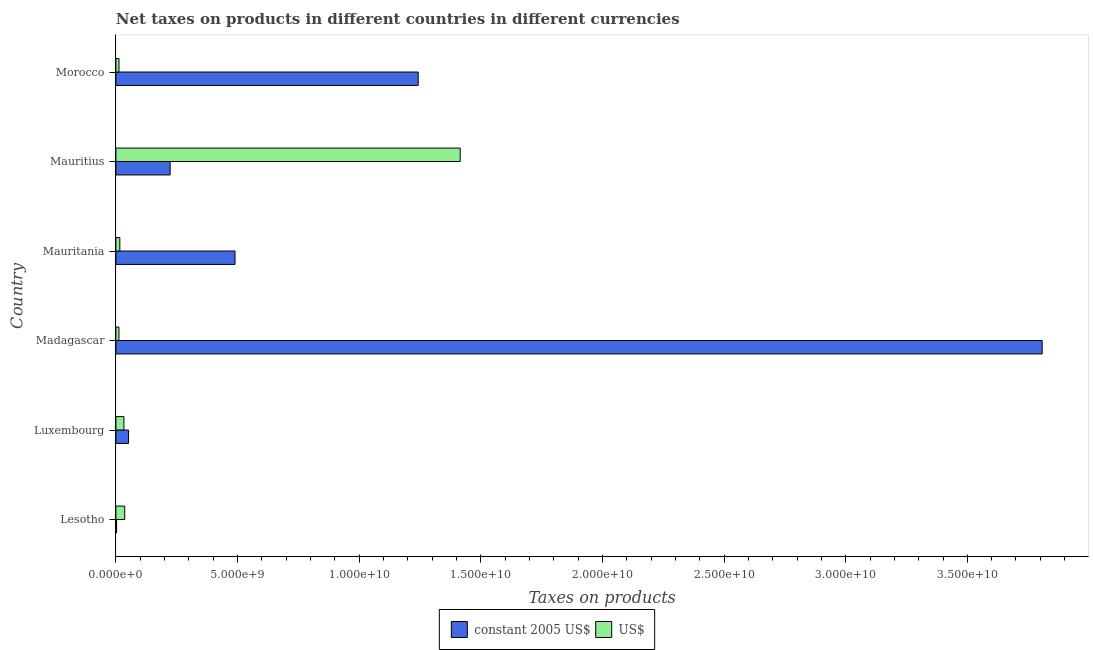How many groups of bars are there?
Your answer should be compact. 6. Are the number of bars per tick equal to the number of legend labels?
Make the answer very short. Yes. Are the number of bars on each tick of the Y-axis equal?
Your answer should be very brief. Yes. How many bars are there on the 5th tick from the bottom?
Provide a short and direct response. 2. What is the label of the 5th group of bars from the top?
Offer a terse response. Luxembourg. In how many cases, is the number of bars for a given country not equal to the number of legend labels?
Your answer should be compact. 0. What is the net taxes in constant 2005 us$ in Lesotho?
Offer a very short reply. 2.91e+07. Across all countries, what is the maximum net taxes in us$?
Your response must be concise. 1.42e+1. Across all countries, what is the minimum net taxes in us$?
Offer a very short reply. 1.26e+08. In which country was the net taxes in constant 2005 us$ maximum?
Offer a very short reply. Madagascar. In which country was the net taxes in us$ minimum?
Offer a terse response. Madagascar. What is the total net taxes in us$ in the graph?
Give a very brief answer. 1.53e+1. What is the difference between the net taxes in us$ in Luxembourg and that in Madagascar?
Ensure brevity in your answer.  2.04e+08. What is the difference between the net taxes in constant 2005 us$ in Luxembourg and the net taxes in us$ in Lesotho?
Make the answer very short. 1.57e+08. What is the average net taxes in constant 2005 us$ per country?
Your answer should be compact. 9.70e+09. What is the difference between the net taxes in us$ and net taxes in constant 2005 us$ in Luxembourg?
Give a very brief answer. -1.89e+08. In how many countries, is the net taxes in constant 2005 us$ greater than 19000000000 units?
Provide a succinct answer. 1. What is the ratio of the net taxes in us$ in Lesotho to that in Morocco?
Provide a short and direct response. 2.85. Is the net taxes in us$ in Luxembourg less than that in Mauritania?
Give a very brief answer. No. Is the difference between the net taxes in us$ in Luxembourg and Madagascar greater than the difference between the net taxes in constant 2005 us$ in Luxembourg and Madagascar?
Provide a succinct answer. Yes. What is the difference between the highest and the second highest net taxes in us$?
Make the answer very short. 1.38e+1. What is the difference between the highest and the lowest net taxes in us$?
Provide a short and direct response. 1.40e+1. In how many countries, is the net taxes in constant 2005 us$ greater than the average net taxes in constant 2005 us$ taken over all countries?
Your answer should be compact. 2. Is the sum of the net taxes in us$ in Madagascar and Mauritius greater than the maximum net taxes in constant 2005 us$ across all countries?
Make the answer very short. No. What does the 1st bar from the top in Madagascar represents?
Provide a short and direct response. US$. What does the 1st bar from the bottom in Mauritius represents?
Make the answer very short. Constant 2005 us$. How many countries are there in the graph?
Give a very brief answer. 6. Does the graph contain grids?
Provide a succinct answer. No. Where does the legend appear in the graph?
Your answer should be very brief. Bottom center. What is the title of the graph?
Your answer should be very brief. Net taxes on products in different countries in different currencies. Does "Under-five" appear as one of the legend labels in the graph?
Offer a very short reply. No. What is the label or title of the X-axis?
Ensure brevity in your answer.  Taxes on products. What is the label or title of the Y-axis?
Your response must be concise. Country. What is the Taxes on products in constant 2005 US$ in Lesotho?
Offer a very short reply. 2.91e+07. What is the Taxes on products of US$ in Lesotho?
Your response must be concise. 3.63e+08. What is the Taxes on products in constant 2005 US$ in Luxembourg?
Keep it short and to the point. 5.20e+08. What is the Taxes on products in US$ in Luxembourg?
Provide a succinct answer. 3.30e+08. What is the Taxes on products of constant 2005 US$ in Madagascar?
Make the answer very short. 3.81e+1. What is the Taxes on products of US$ in Madagascar?
Offer a terse response. 1.26e+08. What is the Taxes on products in constant 2005 US$ in Mauritania?
Your response must be concise. 4.90e+09. What is the Taxes on products of US$ in Mauritania?
Your answer should be compact. 1.62e+08. What is the Taxes on products in constant 2005 US$ in Mauritius?
Give a very brief answer. 2.23e+09. What is the Taxes on products in US$ in Mauritius?
Offer a terse response. 1.42e+1. What is the Taxes on products in constant 2005 US$ in Morocco?
Your answer should be very brief. 1.24e+1. What is the Taxes on products in US$ in Morocco?
Make the answer very short. 1.27e+08. Across all countries, what is the maximum Taxes on products of constant 2005 US$?
Ensure brevity in your answer.  3.81e+1. Across all countries, what is the maximum Taxes on products of US$?
Provide a succinct answer. 1.42e+1. Across all countries, what is the minimum Taxes on products of constant 2005 US$?
Your answer should be very brief. 2.91e+07. Across all countries, what is the minimum Taxes on products of US$?
Keep it short and to the point. 1.26e+08. What is the total Taxes on products in constant 2005 US$ in the graph?
Offer a very short reply. 5.82e+1. What is the total Taxes on products in US$ in the graph?
Offer a terse response. 1.53e+1. What is the difference between the Taxes on products in constant 2005 US$ in Lesotho and that in Luxembourg?
Offer a terse response. -4.91e+08. What is the difference between the Taxes on products in US$ in Lesotho and that in Luxembourg?
Your response must be concise. 3.26e+07. What is the difference between the Taxes on products in constant 2005 US$ in Lesotho and that in Madagascar?
Provide a succinct answer. -3.80e+1. What is the difference between the Taxes on products of US$ in Lesotho and that in Madagascar?
Give a very brief answer. 2.37e+08. What is the difference between the Taxes on products in constant 2005 US$ in Lesotho and that in Mauritania?
Ensure brevity in your answer.  -4.87e+09. What is the difference between the Taxes on products in US$ in Lesotho and that in Mauritania?
Offer a very short reply. 2.01e+08. What is the difference between the Taxes on products of constant 2005 US$ in Lesotho and that in Mauritius?
Your answer should be compact. -2.20e+09. What is the difference between the Taxes on products in US$ in Lesotho and that in Mauritius?
Your answer should be very brief. -1.38e+1. What is the difference between the Taxes on products in constant 2005 US$ in Lesotho and that in Morocco?
Provide a short and direct response. -1.24e+1. What is the difference between the Taxes on products of US$ in Lesotho and that in Morocco?
Your response must be concise. 2.36e+08. What is the difference between the Taxes on products in constant 2005 US$ in Luxembourg and that in Madagascar?
Make the answer very short. -3.76e+1. What is the difference between the Taxes on products of US$ in Luxembourg and that in Madagascar?
Provide a succinct answer. 2.04e+08. What is the difference between the Taxes on products of constant 2005 US$ in Luxembourg and that in Mauritania?
Offer a terse response. -4.38e+09. What is the difference between the Taxes on products of US$ in Luxembourg and that in Mauritania?
Ensure brevity in your answer.  1.69e+08. What is the difference between the Taxes on products in constant 2005 US$ in Luxembourg and that in Mauritius?
Offer a very short reply. -1.71e+09. What is the difference between the Taxes on products in US$ in Luxembourg and that in Mauritius?
Provide a short and direct response. -1.38e+1. What is the difference between the Taxes on products in constant 2005 US$ in Luxembourg and that in Morocco?
Your answer should be very brief. -1.19e+1. What is the difference between the Taxes on products of US$ in Luxembourg and that in Morocco?
Your answer should be compact. 2.03e+08. What is the difference between the Taxes on products in constant 2005 US$ in Madagascar and that in Mauritania?
Your response must be concise. 3.32e+1. What is the difference between the Taxes on products of US$ in Madagascar and that in Mauritania?
Offer a terse response. -3.56e+07. What is the difference between the Taxes on products of constant 2005 US$ in Madagascar and that in Mauritius?
Make the answer very short. 3.58e+1. What is the difference between the Taxes on products in US$ in Madagascar and that in Mauritius?
Your answer should be compact. -1.40e+1. What is the difference between the Taxes on products in constant 2005 US$ in Madagascar and that in Morocco?
Offer a very short reply. 2.56e+1. What is the difference between the Taxes on products in US$ in Madagascar and that in Morocco?
Make the answer very short. -1.25e+06. What is the difference between the Taxes on products of constant 2005 US$ in Mauritania and that in Mauritius?
Make the answer very short. 2.67e+09. What is the difference between the Taxes on products of US$ in Mauritania and that in Mauritius?
Your answer should be very brief. -1.40e+1. What is the difference between the Taxes on products in constant 2005 US$ in Mauritania and that in Morocco?
Offer a very short reply. -7.53e+09. What is the difference between the Taxes on products in US$ in Mauritania and that in Morocco?
Your answer should be very brief. 3.43e+07. What is the difference between the Taxes on products in constant 2005 US$ in Mauritius and that in Morocco?
Offer a very short reply. -1.02e+1. What is the difference between the Taxes on products in US$ in Mauritius and that in Morocco?
Your answer should be compact. 1.40e+1. What is the difference between the Taxes on products of constant 2005 US$ in Lesotho and the Taxes on products of US$ in Luxembourg?
Keep it short and to the point. -3.01e+08. What is the difference between the Taxes on products of constant 2005 US$ in Lesotho and the Taxes on products of US$ in Madagascar?
Provide a succinct answer. -9.69e+07. What is the difference between the Taxes on products of constant 2005 US$ in Lesotho and the Taxes on products of US$ in Mauritania?
Provide a succinct answer. -1.32e+08. What is the difference between the Taxes on products in constant 2005 US$ in Lesotho and the Taxes on products in US$ in Mauritius?
Provide a succinct answer. -1.41e+1. What is the difference between the Taxes on products in constant 2005 US$ in Lesotho and the Taxes on products in US$ in Morocco?
Your answer should be very brief. -9.82e+07. What is the difference between the Taxes on products in constant 2005 US$ in Luxembourg and the Taxes on products in US$ in Madagascar?
Your answer should be very brief. 3.94e+08. What is the difference between the Taxes on products in constant 2005 US$ in Luxembourg and the Taxes on products in US$ in Mauritania?
Ensure brevity in your answer.  3.58e+08. What is the difference between the Taxes on products of constant 2005 US$ in Luxembourg and the Taxes on products of US$ in Mauritius?
Keep it short and to the point. -1.36e+1. What is the difference between the Taxes on products of constant 2005 US$ in Luxembourg and the Taxes on products of US$ in Morocco?
Your answer should be very brief. 3.92e+08. What is the difference between the Taxes on products of constant 2005 US$ in Madagascar and the Taxes on products of US$ in Mauritania?
Provide a succinct answer. 3.79e+1. What is the difference between the Taxes on products in constant 2005 US$ in Madagascar and the Taxes on products in US$ in Mauritius?
Offer a terse response. 2.39e+1. What is the difference between the Taxes on products of constant 2005 US$ in Madagascar and the Taxes on products of US$ in Morocco?
Keep it short and to the point. 3.79e+1. What is the difference between the Taxes on products of constant 2005 US$ in Mauritania and the Taxes on products of US$ in Mauritius?
Make the answer very short. -9.26e+09. What is the difference between the Taxes on products in constant 2005 US$ in Mauritania and the Taxes on products in US$ in Morocco?
Keep it short and to the point. 4.77e+09. What is the difference between the Taxes on products in constant 2005 US$ in Mauritius and the Taxes on products in US$ in Morocco?
Keep it short and to the point. 2.10e+09. What is the average Taxes on products of constant 2005 US$ per country?
Your answer should be compact. 9.70e+09. What is the average Taxes on products of US$ per country?
Ensure brevity in your answer.  2.54e+09. What is the difference between the Taxes on products of constant 2005 US$ and Taxes on products of US$ in Lesotho?
Offer a terse response. -3.34e+08. What is the difference between the Taxes on products in constant 2005 US$ and Taxes on products in US$ in Luxembourg?
Offer a terse response. 1.89e+08. What is the difference between the Taxes on products of constant 2005 US$ and Taxes on products of US$ in Madagascar?
Your response must be concise. 3.80e+1. What is the difference between the Taxes on products in constant 2005 US$ and Taxes on products in US$ in Mauritania?
Make the answer very short. 4.74e+09. What is the difference between the Taxes on products of constant 2005 US$ and Taxes on products of US$ in Mauritius?
Offer a terse response. -1.19e+1. What is the difference between the Taxes on products of constant 2005 US$ and Taxes on products of US$ in Morocco?
Your answer should be very brief. 1.23e+1. What is the ratio of the Taxes on products in constant 2005 US$ in Lesotho to that in Luxembourg?
Ensure brevity in your answer.  0.06. What is the ratio of the Taxes on products in US$ in Lesotho to that in Luxembourg?
Your response must be concise. 1.1. What is the ratio of the Taxes on products of constant 2005 US$ in Lesotho to that in Madagascar?
Offer a terse response. 0. What is the ratio of the Taxes on products in US$ in Lesotho to that in Madagascar?
Offer a very short reply. 2.88. What is the ratio of the Taxes on products of constant 2005 US$ in Lesotho to that in Mauritania?
Keep it short and to the point. 0.01. What is the ratio of the Taxes on products in US$ in Lesotho to that in Mauritania?
Your response must be concise. 2.25. What is the ratio of the Taxes on products of constant 2005 US$ in Lesotho to that in Mauritius?
Ensure brevity in your answer.  0.01. What is the ratio of the Taxes on products in US$ in Lesotho to that in Mauritius?
Make the answer very short. 0.03. What is the ratio of the Taxes on products in constant 2005 US$ in Lesotho to that in Morocco?
Provide a succinct answer. 0. What is the ratio of the Taxes on products of US$ in Lesotho to that in Morocco?
Keep it short and to the point. 2.85. What is the ratio of the Taxes on products in constant 2005 US$ in Luxembourg to that in Madagascar?
Give a very brief answer. 0.01. What is the ratio of the Taxes on products in US$ in Luxembourg to that in Madagascar?
Give a very brief answer. 2.62. What is the ratio of the Taxes on products in constant 2005 US$ in Luxembourg to that in Mauritania?
Provide a short and direct response. 0.11. What is the ratio of the Taxes on products in US$ in Luxembourg to that in Mauritania?
Your answer should be very brief. 2.04. What is the ratio of the Taxes on products in constant 2005 US$ in Luxembourg to that in Mauritius?
Provide a short and direct response. 0.23. What is the ratio of the Taxes on products of US$ in Luxembourg to that in Mauritius?
Offer a terse response. 0.02. What is the ratio of the Taxes on products of constant 2005 US$ in Luxembourg to that in Morocco?
Your response must be concise. 0.04. What is the ratio of the Taxes on products of US$ in Luxembourg to that in Morocco?
Your answer should be compact. 2.59. What is the ratio of the Taxes on products in constant 2005 US$ in Madagascar to that in Mauritania?
Your response must be concise. 7.78. What is the ratio of the Taxes on products of US$ in Madagascar to that in Mauritania?
Your answer should be very brief. 0.78. What is the ratio of the Taxes on products of constant 2005 US$ in Madagascar to that in Mauritius?
Keep it short and to the point. 17.08. What is the ratio of the Taxes on products of US$ in Madagascar to that in Mauritius?
Keep it short and to the point. 0.01. What is the ratio of the Taxes on products in constant 2005 US$ in Madagascar to that in Morocco?
Make the answer very short. 3.06. What is the ratio of the Taxes on products in US$ in Madagascar to that in Morocco?
Make the answer very short. 0.99. What is the ratio of the Taxes on products of constant 2005 US$ in Mauritania to that in Mauritius?
Give a very brief answer. 2.2. What is the ratio of the Taxes on products in US$ in Mauritania to that in Mauritius?
Your answer should be very brief. 0.01. What is the ratio of the Taxes on products of constant 2005 US$ in Mauritania to that in Morocco?
Your answer should be very brief. 0.39. What is the ratio of the Taxes on products in US$ in Mauritania to that in Morocco?
Offer a very short reply. 1.27. What is the ratio of the Taxes on products in constant 2005 US$ in Mauritius to that in Morocco?
Keep it short and to the point. 0.18. What is the ratio of the Taxes on products in US$ in Mauritius to that in Morocco?
Give a very brief answer. 111.22. What is the difference between the highest and the second highest Taxes on products in constant 2005 US$?
Provide a succinct answer. 2.56e+1. What is the difference between the highest and the second highest Taxes on products of US$?
Your answer should be very brief. 1.38e+1. What is the difference between the highest and the lowest Taxes on products of constant 2005 US$?
Provide a succinct answer. 3.80e+1. What is the difference between the highest and the lowest Taxes on products in US$?
Your response must be concise. 1.40e+1. 